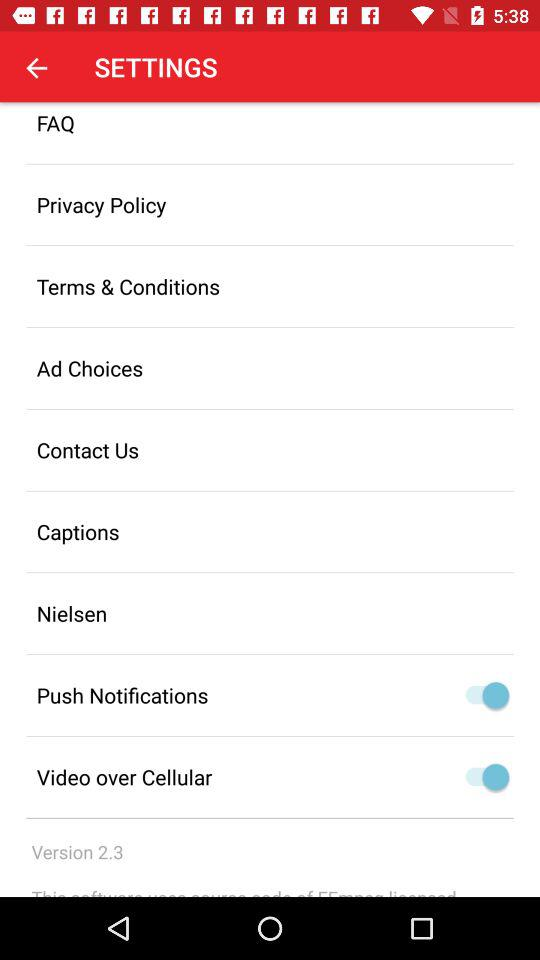What's the status of "Push Notifications"? The status is "on". 